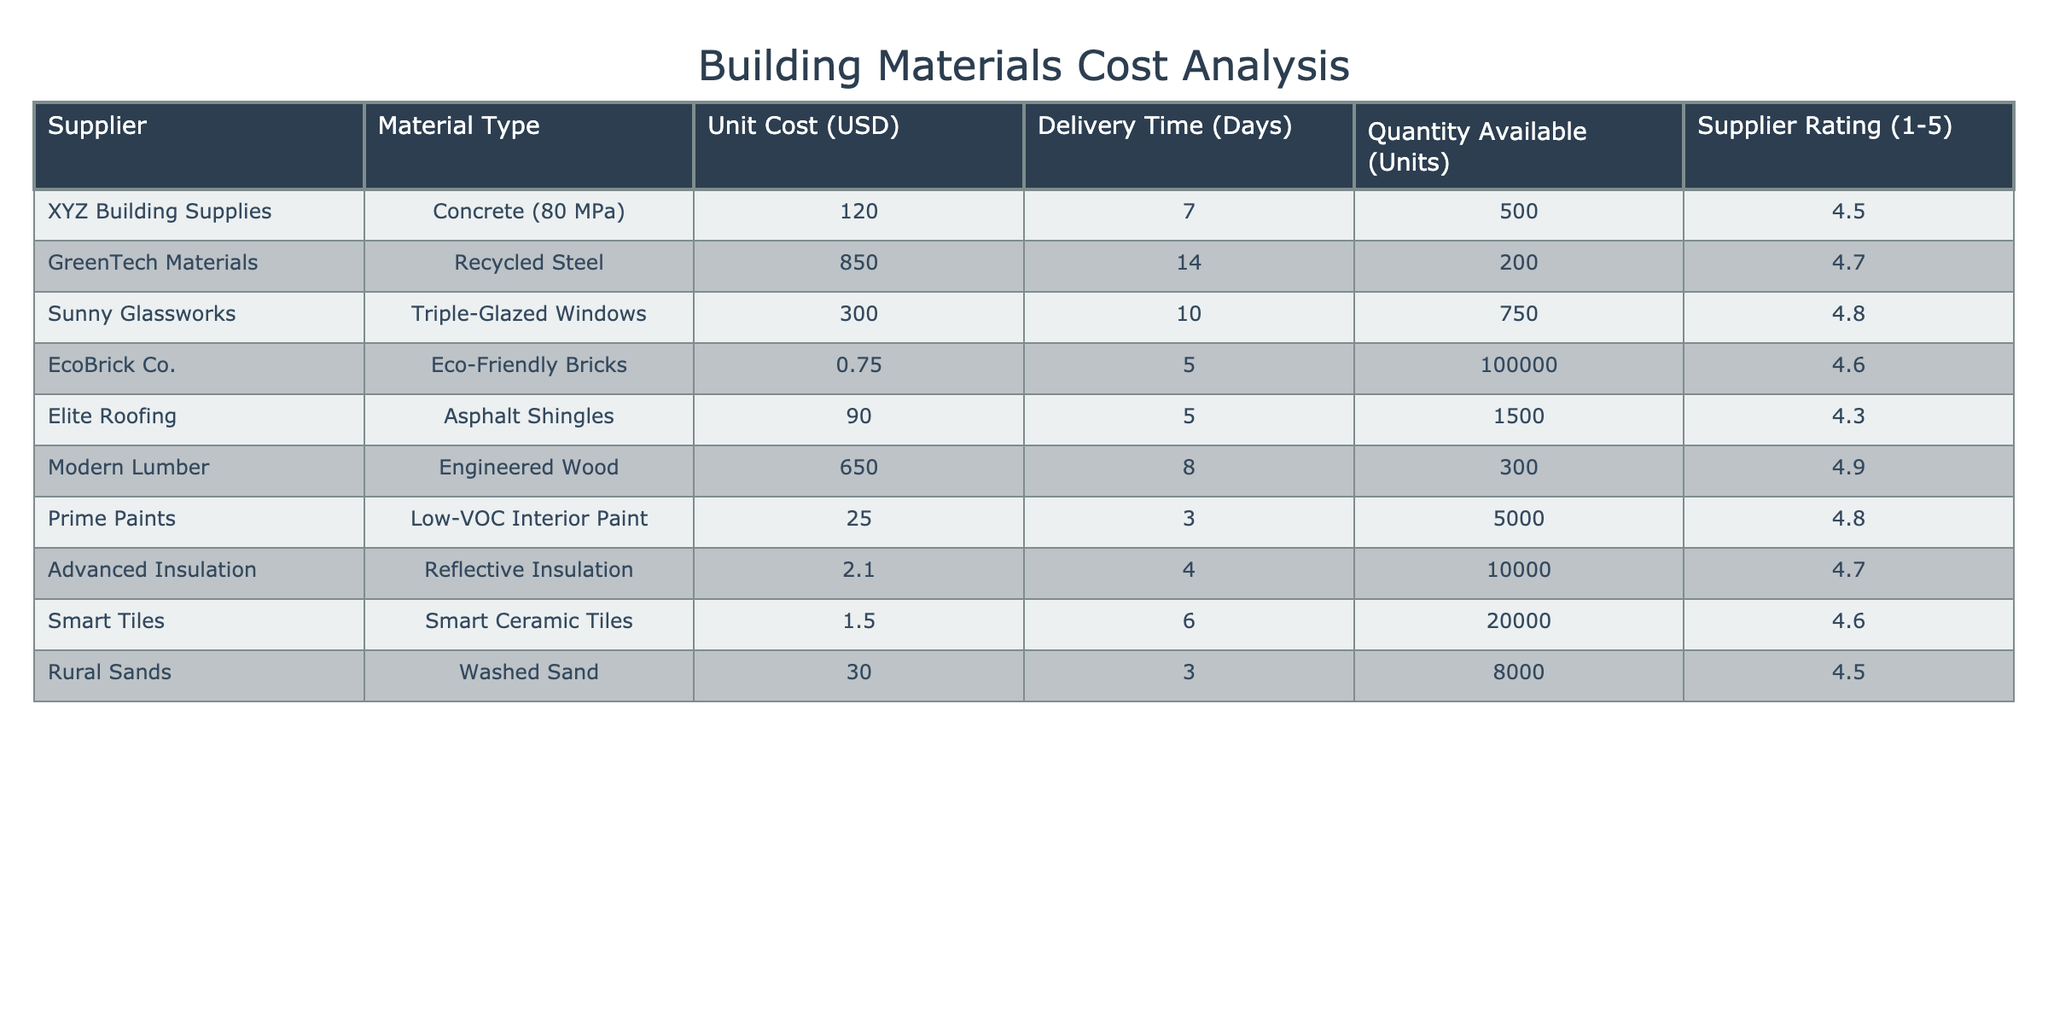What is the unit cost of Eco-Friendly Bricks? The table lists the unit cost for Eco-Friendly Bricks under the corresponding supplier, which is 0.75 USD.
Answer: 0.75 USD Which supplier has the highest supplier rating? Looking at the supplier ratings in the table, GreenTech Materials has the highest rating of 4.7.
Answer: GreenTech Materials What is the average unit cost of the materials provided in the table? The total unit cost sums up to (120 + 850 + 300 + 0.75 + 90 + 650 + 25 + 2.1 + 1.5 + 30) = 2069.35, and there are 10 suppliers. Thus, the average is 2069.35 / 10 = 206.935.
Answer: 206.94 USD Is the delivery time for Recycled Steel less than for Asphalt Shingles? The delivery time for Recycled Steel is 14 days, while for Asphalt Shingles, it's 5 days, which confirms that Recycled Steel has a longer delivery time.
Answer: No How many units of Concrete (80 MPa) are available compared to Smart Ceramic Tiles? The table shows 500 units of Concrete and 20,000 units of Smart Ceramic Tiles. Since 20,000 > 500, Smart Ceramic Tiles has significantly more available units.
Answer: Smart Ceramic Tiles has more units available What is the total quantity available of materials provided by suppliers rated 4.5 and above? Only suppliers with ratings 4.5 and above are included: XYZ Building Supplies (500), GreenTech Materials (200), Sunny Glassworks (750), EcoBrick Co. (100,000), Modern Lumber (300), Prime Paints (5,000), Advanced Insulation (10,000), Smart Tiles (20,000), and Rural Sands (8,000). Summing these gives 500 + 200 + 750 + 100000 + 300 + 5000 + 10000 + 20000 + 8000 = 148,760 units.
Answer: 148,760 units Which material has the lowest unit cost and what is the cost? Examining the table, Smart Ceramic Tiles at 1.50 USD and Eco-Friendly Bricks at 0.75 USD are both low costs, but Eco-Friendly Bricks is lower.
Answer: 0.75 USD Are there any materials with a unit cost less than 10 USD? The lowest unit cost materials are 0.75 USD for Eco-Friendly Bricks and 1.50 USD for Smart Ceramic Tiles, both of which are below 10 USD.
Answer: Yes Which supplier delivers at the fastest time and what is that time? By checking the delivery times, both EcoBrick Co. and Elite Roofing have the fastest delivery of 5 days.
Answer: 5 days 